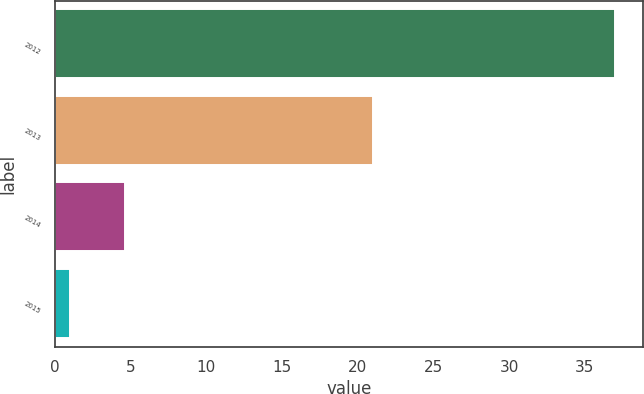Convert chart to OTSL. <chart><loc_0><loc_0><loc_500><loc_500><bar_chart><fcel>2012<fcel>2013<fcel>2014<fcel>2015<nl><fcel>37<fcel>21<fcel>4.6<fcel>1<nl></chart> 